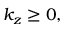<formula> <loc_0><loc_0><loc_500><loc_500>k _ { z } \geq 0 ,</formula> 